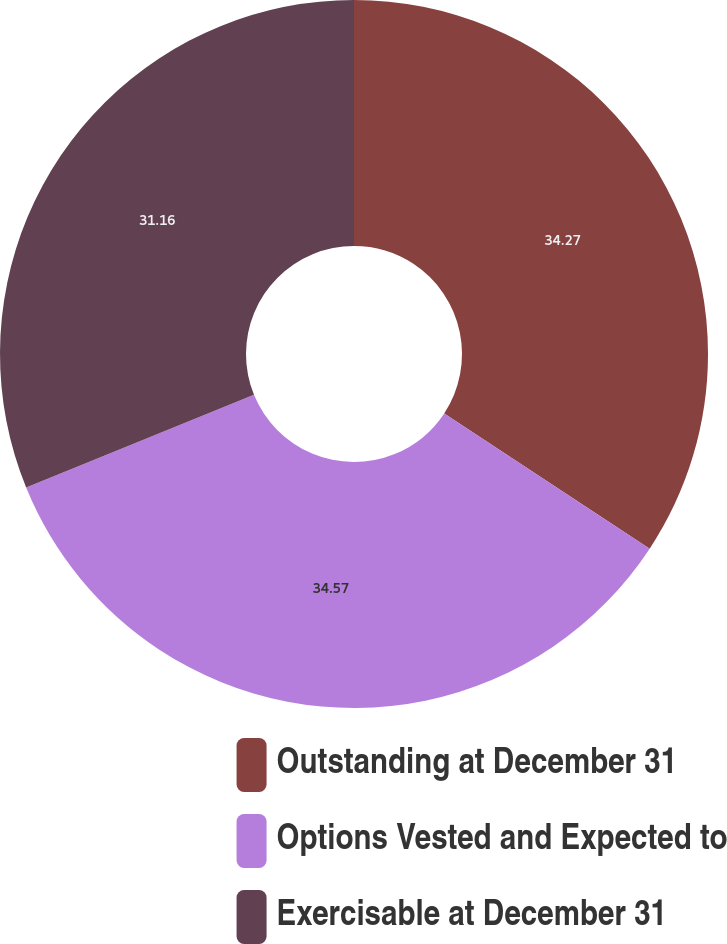<chart> <loc_0><loc_0><loc_500><loc_500><pie_chart><fcel>Outstanding at December 31<fcel>Options Vested and Expected to<fcel>Exercisable at December 31<nl><fcel>34.27%<fcel>34.58%<fcel>31.16%<nl></chart> 